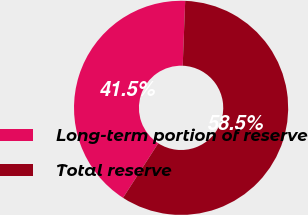<chart> <loc_0><loc_0><loc_500><loc_500><pie_chart><fcel>Long-term portion of reserve<fcel>Total reserve<nl><fcel>41.49%<fcel>58.51%<nl></chart> 